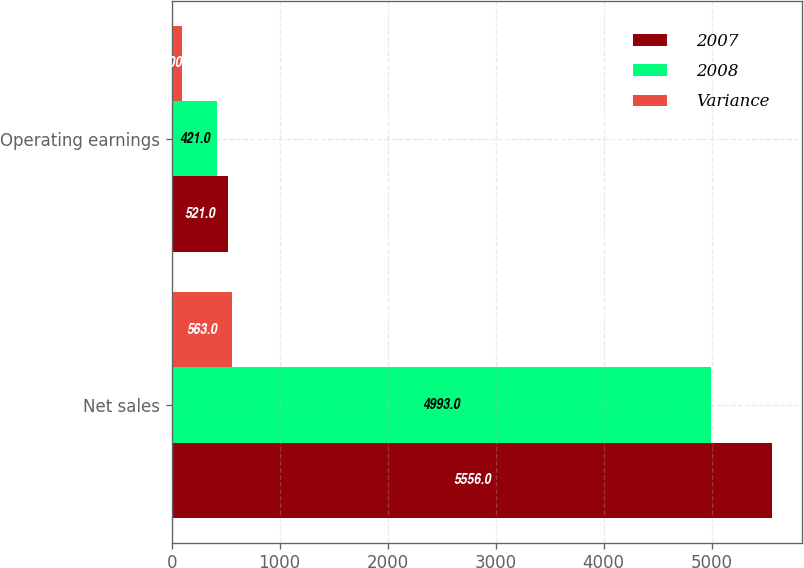<chart> <loc_0><loc_0><loc_500><loc_500><stacked_bar_chart><ecel><fcel>Net sales<fcel>Operating earnings<nl><fcel>2007<fcel>5556<fcel>521<nl><fcel>2008<fcel>4993<fcel>421<nl><fcel>Variance<fcel>563<fcel>100<nl></chart> 